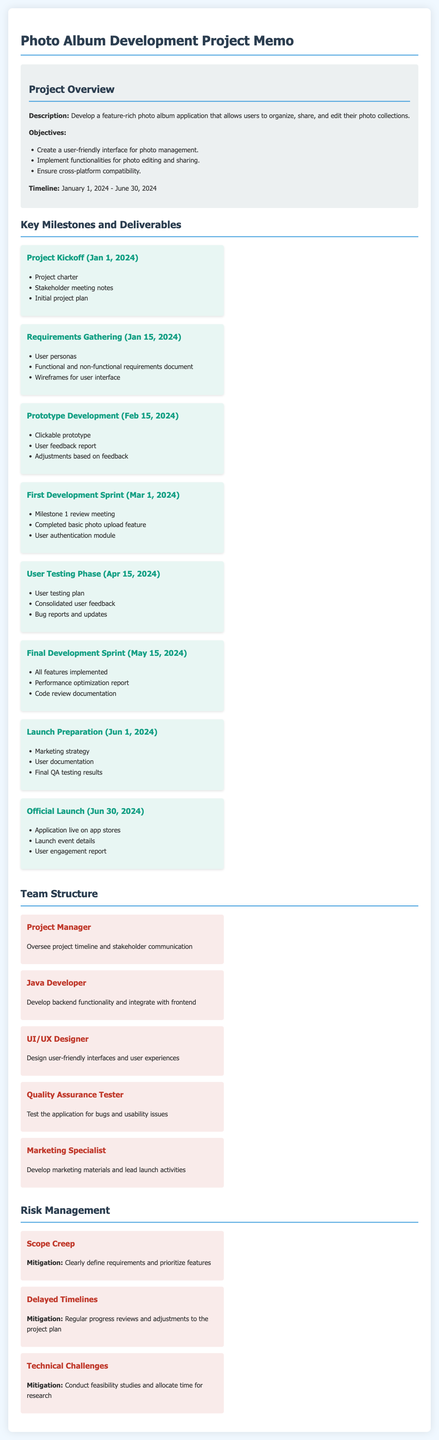What is the project timeline? The document specifies the project timeline as January 1, 2024 - June 30, 2024.
Answer: January 1, 2024 - June 30, 2024 What is the first milestone of the project? The first milestone mentioned is the project kickoff, which takes place on January 1, 2024.
Answer: Project Kickoff What is the deliverable for the User Testing Phase? The deliverable during the User Testing Phase includes the consolidated user feedback.
Answer: Consolidated user feedback What team role is responsible for developing marketing materials? The Marketing Specialist is the team member responsible for developing marketing materials.
Answer: Marketing Specialist What is the risk associated with delayed timelines? The risk associated with delayed timelines is mentioned in the document as having regular progress reviews and adjustments to the project plan as mitigation.
Answer: Delayed Timelines How many key milestones are listed in the document? The document lists a total of 7 key milestones and deliverables for the project.
Answer: 7 What is the last milestone listed? The last milestone listed in the document is the Official Launch, occurring on June 30, 2024.
Answer: Official Launch What is the primary goal of the project? The primary goal of the project is to develop a feature-rich photo album application.
Answer: Feature-rich photo album application 